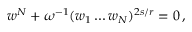Convert formula to latex. <formula><loc_0><loc_0><loc_500><loc_500>w ^ { N } + \omega ^ { - 1 } ( w _ { 1 } \dots w _ { N } ) ^ { 2 s / r } = 0 \, ,</formula> 